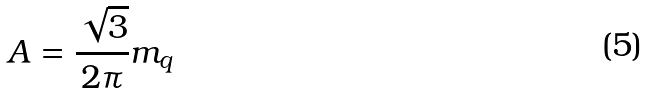Convert formula to latex. <formula><loc_0><loc_0><loc_500><loc_500>A = \frac { \sqrt { 3 } } { 2 \pi } m _ { q }</formula> 